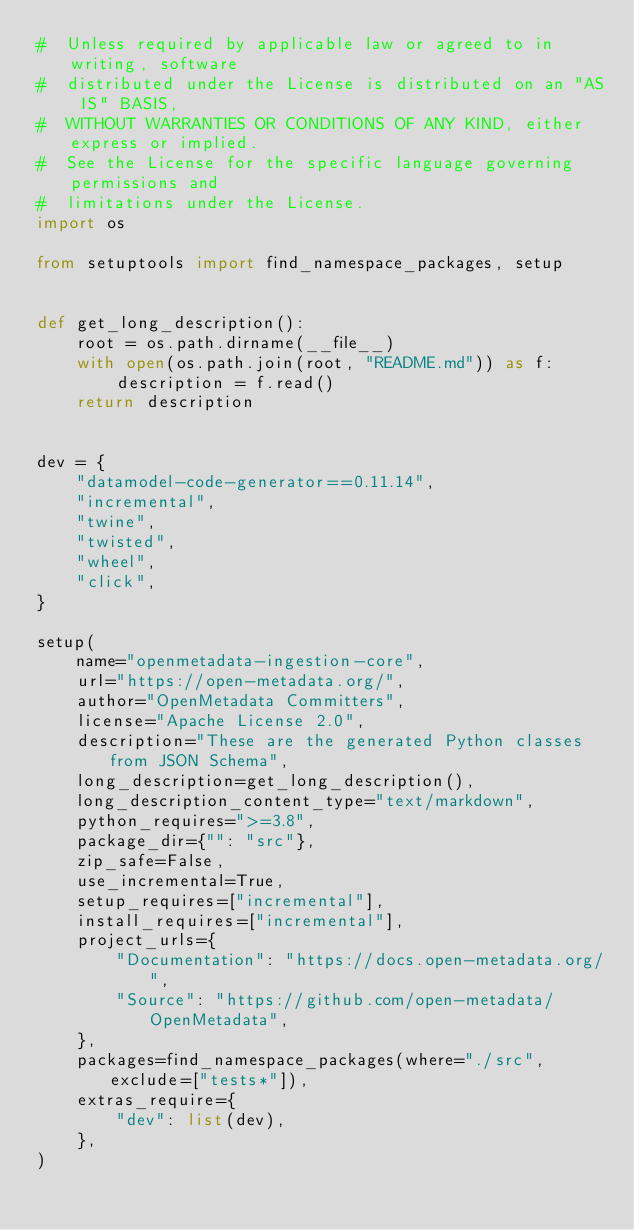Convert code to text. <code><loc_0><loc_0><loc_500><loc_500><_Python_>#  Unless required by applicable law or agreed to in writing, software
#  distributed under the License is distributed on an "AS IS" BASIS,
#  WITHOUT WARRANTIES OR CONDITIONS OF ANY KIND, either express or implied.
#  See the License for the specific language governing permissions and
#  limitations under the License.
import os

from setuptools import find_namespace_packages, setup


def get_long_description():
    root = os.path.dirname(__file__)
    with open(os.path.join(root, "README.md")) as f:
        description = f.read()
    return description


dev = {
    "datamodel-code-generator==0.11.14",
    "incremental",
    "twine",
    "twisted",
    "wheel",
    "click",
}

setup(
    name="openmetadata-ingestion-core",
    url="https://open-metadata.org/",
    author="OpenMetadata Committers",
    license="Apache License 2.0",
    description="These are the generated Python classes from JSON Schema",
    long_description=get_long_description(),
    long_description_content_type="text/markdown",
    python_requires=">=3.8",
    package_dir={"": "src"},
    zip_safe=False,
    use_incremental=True,
    setup_requires=["incremental"],
    install_requires=["incremental"],
    project_urls={
        "Documentation": "https://docs.open-metadata.org/",
        "Source": "https://github.com/open-metadata/OpenMetadata",
    },
    packages=find_namespace_packages(where="./src", exclude=["tests*"]),
    extras_require={
        "dev": list(dev),
    },
)
</code> 